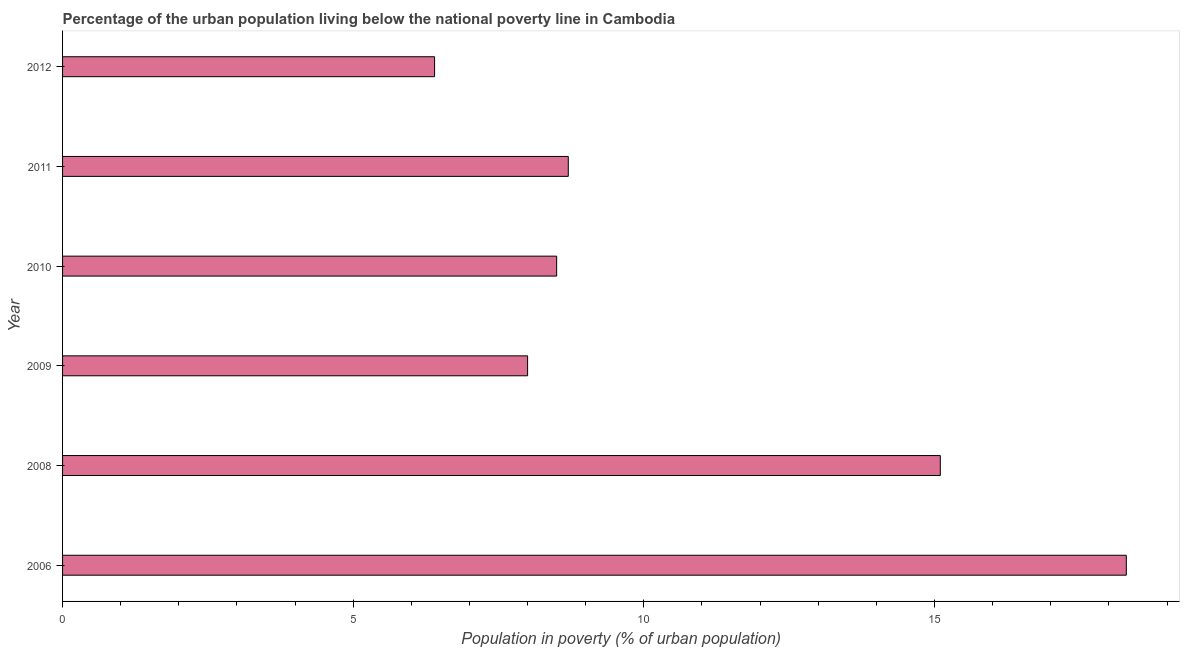Does the graph contain any zero values?
Offer a terse response. No. Does the graph contain grids?
Provide a short and direct response. No. What is the title of the graph?
Ensure brevity in your answer.  Percentage of the urban population living below the national poverty line in Cambodia. What is the label or title of the X-axis?
Keep it short and to the point. Population in poverty (% of urban population). Across all years, what is the maximum percentage of urban population living below poverty line?
Ensure brevity in your answer.  18.3. What is the average percentage of urban population living below poverty line per year?
Your answer should be very brief. 10.83. What is the median percentage of urban population living below poverty line?
Offer a terse response. 8.6. In how many years, is the percentage of urban population living below poverty line greater than 2 %?
Provide a short and direct response. 6. Do a majority of the years between 2006 and 2010 (inclusive) have percentage of urban population living below poverty line greater than 15 %?
Offer a terse response. No. What is the ratio of the percentage of urban population living below poverty line in 2008 to that in 2011?
Offer a terse response. 1.74. Is the difference between the percentage of urban population living below poverty line in 2010 and 2012 greater than the difference between any two years?
Keep it short and to the point. No. Are the values on the major ticks of X-axis written in scientific E-notation?
Provide a short and direct response. No. What is the Population in poverty (% of urban population) in 2009?
Offer a terse response. 8. What is the Population in poverty (% of urban population) of 2010?
Provide a succinct answer. 8.5. What is the Population in poverty (% of urban population) of 2011?
Provide a short and direct response. 8.7. What is the difference between the Population in poverty (% of urban population) in 2006 and 2008?
Your response must be concise. 3.2. What is the difference between the Population in poverty (% of urban population) in 2006 and 2009?
Offer a very short reply. 10.3. What is the difference between the Population in poverty (% of urban population) in 2006 and 2010?
Ensure brevity in your answer.  9.8. What is the difference between the Population in poverty (% of urban population) in 2008 and 2010?
Provide a succinct answer. 6.6. What is the difference between the Population in poverty (% of urban population) in 2008 and 2011?
Keep it short and to the point. 6.4. What is the difference between the Population in poverty (% of urban population) in 2009 and 2010?
Make the answer very short. -0.5. What is the difference between the Population in poverty (% of urban population) in 2009 and 2012?
Provide a short and direct response. 1.6. What is the ratio of the Population in poverty (% of urban population) in 2006 to that in 2008?
Offer a terse response. 1.21. What is the ratio of the Population in poverty (% of urban population) in 2006 to that in 2009?
Give a very brief answer. 2.29. What is the ratio of the Population in poverty (% of urban population) in 2006 to that in 2010?
Offer a very short reply. 2.15. What is the ratio of the Population in poverty (% of urban population) in 2006 to that in 2011?
Give a very brief answer. 2.1. What is the ratio of the Population in poverty (% of urban population) in 2006 to that in 2012?
Ensure brevity in your answer.  2.86. What is the ratio of the Population in poverty (% of urban population) in 2008 to that in 2009?
Offer a very short reply. 1.89. What is the ratio of the Population in poverty (% of urban population) in 2008 to that in 2010?
Ensure brevity in your answer.  1.78. What is the ratio of the Population in poverty (% of urban population) in 2008 to that in 2011?
Give a very brief answer. 1.74. What is the ratio of the Population in poverty (% of urban population) in 2008 to that in 2012?
Your answer should be very brief. 2.36. What is the ratio of the Population in poverty (% of urban population) in 2009 to that in 2010?
Offer a very short reply. 0.94. What is the ratio of the Population in poverty (% of urban population) in 2009 to that in 2011?
Make the answer very short. 0.92. What is the ratio of the Population in poverty (% of urban population) in 2010 to that in 2012?
Give a very brief answer. 1.33. What is the ratio of the Population in poverty (% of urban population) in 2011 to that in 2012?
Keep it short and to the point. 1.36. 